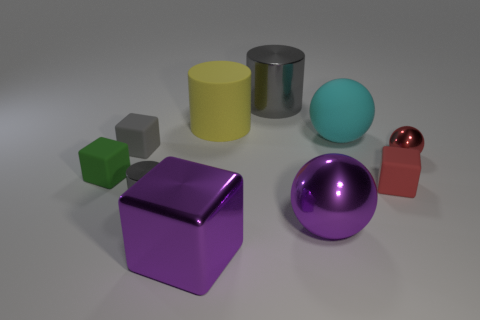Can you tell me what the small green object on the left is meant to represent? The small green object appears to be a cube. It might represent a geometric shape for educational purposes or simply be part of a set of objects for visual or artistic display. 